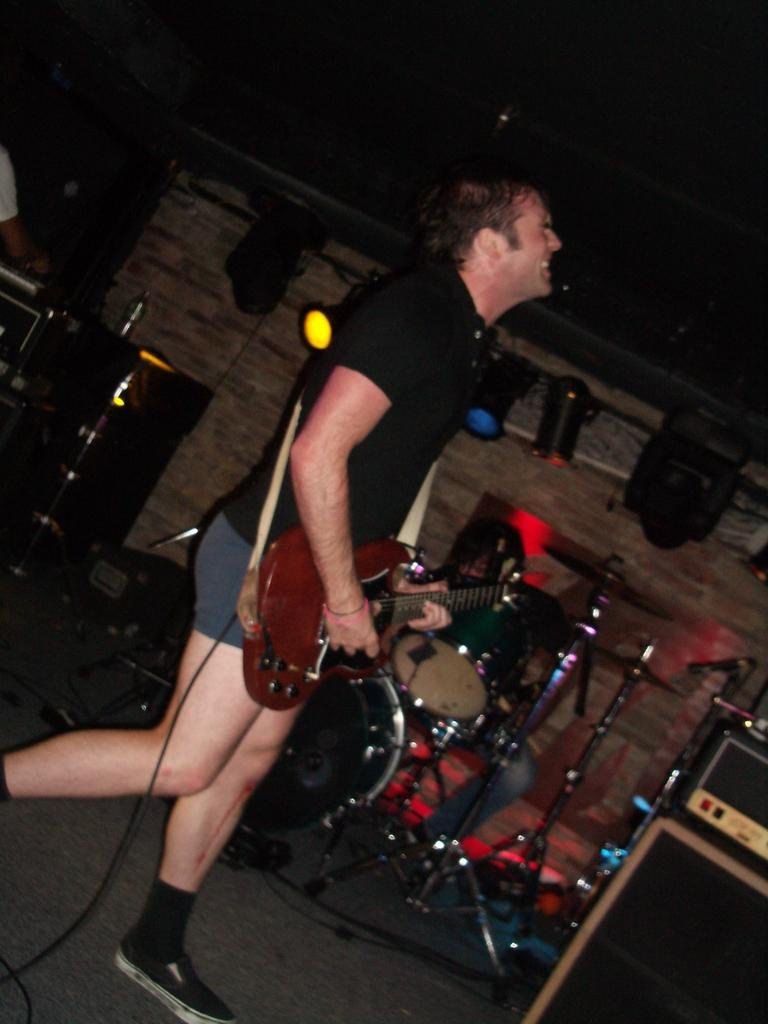What is the main subject of the image? There is a person in the image. What is the person wearing? The person is wearing a black shirt. What is the person holding in the image? The person is holding a guitar. What else can be seen in the image besides the person and the guitar? There are lights visible in the image, and there are other musical instruments present. What type of milk is the person drinking in the image? There is no milk present in the image; the person is holding a guitar and there are other musical instruments visible. 